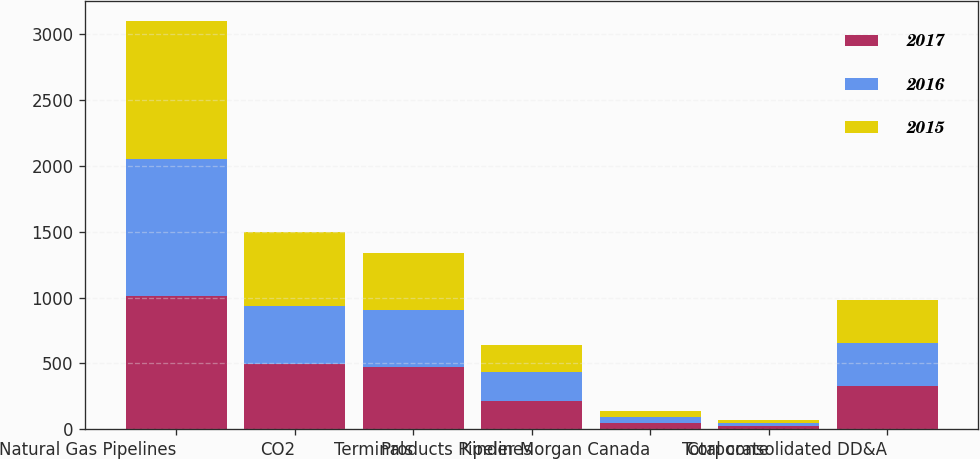Convert chart. <chart><loc_0><loc_0><loc_500><loc_500><stacked_bar_chart><ecel><fcel>Natural Gas Pipelines<fcel>CO2<fcel>Terminals<fcel>Products Pipelines<fcel>Kinder Morgan Canada<fcel>Corporate<fcel>Total consolidated DD&A<nl><fcel>2017<fcel>1011<fcel>493<fcel>472<fcel>216<fcel>46<fcel>23<fcel>327<nl><fcel>2016<fcel>1041<fcel>446<fcel>435<fcel>221<fcel>44<fcel>22<fcel>327<nl><fcel>2015<fcel>1046<fcel>556<fcel>433<fcel>206<fcel>46<fcel>22<fcel>327<nl></chart> 